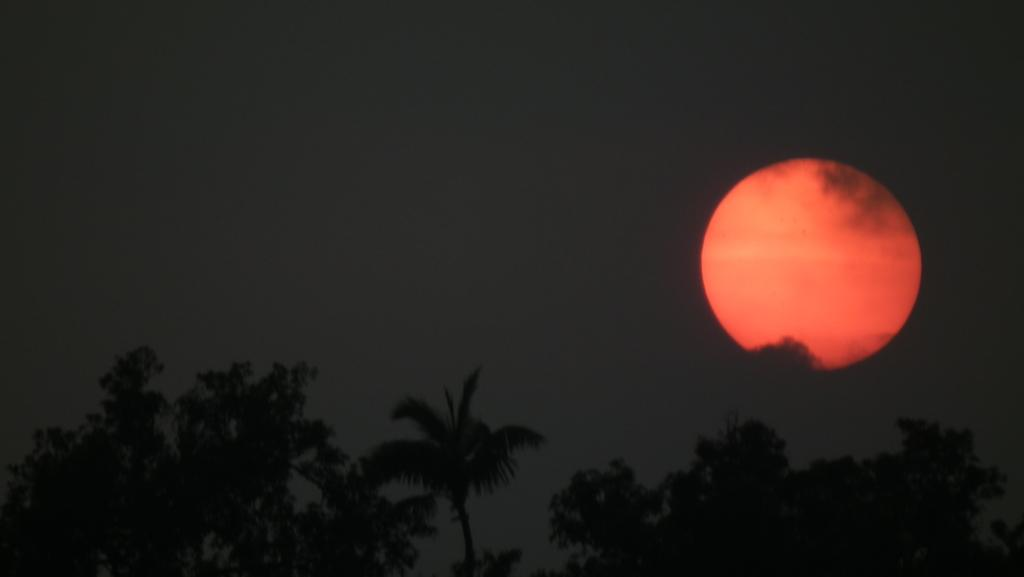What type of vegetation is present in the image? There are many trees in the image. What celestial body can be seen in the image? The moon is visible in the image. What part of the natural environment is visible in the image? The sky is visible in the image. What type of brass mask can be seen hanging from one of the trees in the image? There is no brass mask present in the image; it only features trees, the moon, and the sky. 